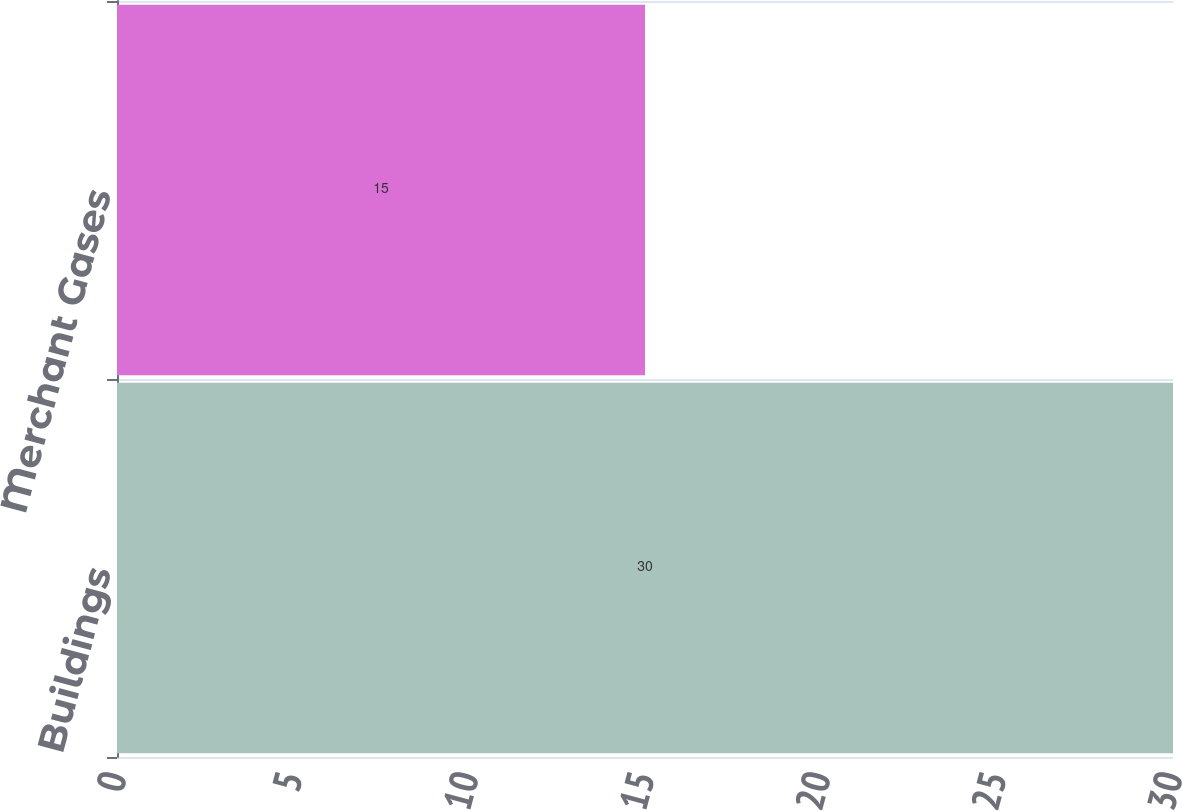Convert chart to OTSL. <chart><loc_0><loc_0><loc_500><loc_500><bar_chart><fcel>Buildings<fcel>Merchant Gases<nl><fcel>30<fcel>15<nl></chart> 